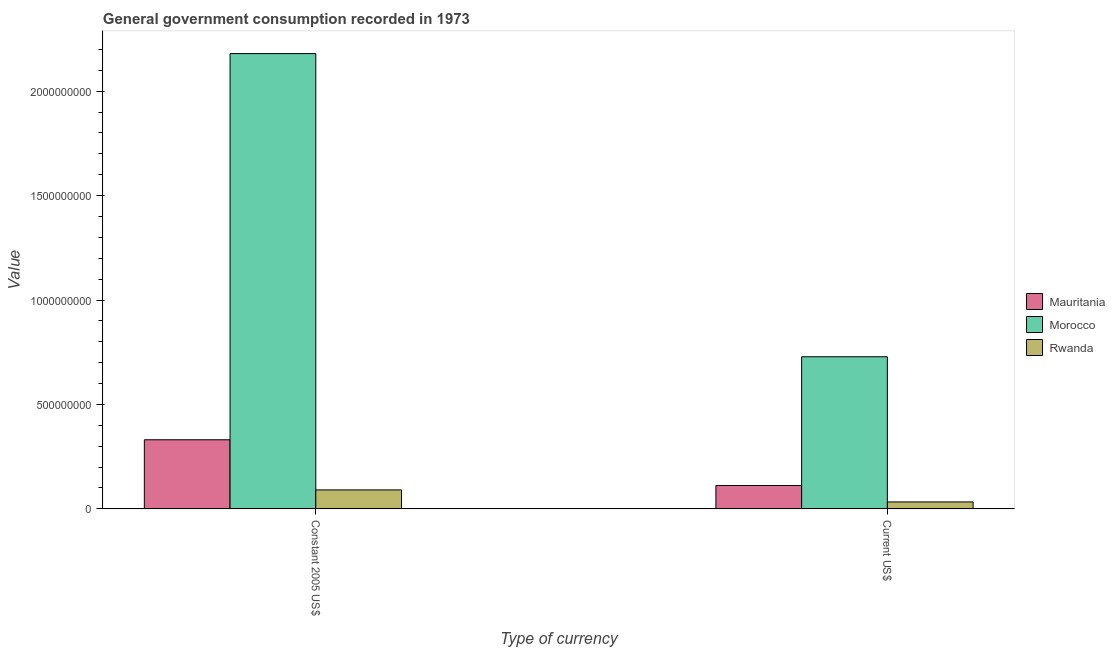How many different coloured bars are there?
Your response must be concise. 3. Are the number of bars per tick equal to the number of legend labels?
Offer a terse response. Yes. How many bars are there on the 1st tick from the left?
Provide a succinct answer. 3. What is the label of the 1st group of bars from the left?
Ensure brevity in your answer.  Constant 2005 US$. What is the value consumed in constant 2005 us$ in Rwanda?
Your answer should be compact. 9.06e+07. Across all countries, what is the maximum value consumed in current us$?
Your answer should be very brief. 7.28e+08. Across all countries, what is the minimum value consumed in current us$?
Give a very brief answer. 3.31e+07. In which country was the value consumed in current us$ maximum?
Offer a terse response. Morocco. In which country was the value consumed in current us$ minimum?
Ensure brevity in your answer.  Rwanda. What is the total value consumed in current us$ in the graph?
Offer a very short reply. 8.73e+08. What is the difference between the value consumed in current us$ in Rwanda and that in Morocco?
Keep it short and to the point. -6.95e+08. What is the difference between the value consumed in current us$ in Rwanda and the value consumed in constant 2005 us$ in Morocco?
Make the answer very short. -2.15e+09. What is the average value consumed in constant 2005 us$ per country?
Give a very brief answer. 8.67e+08. What is the difference between the value consumed in current us$ and value consumed in constant 2005 us$ in Morocco?
Ensure brevity in your answer.  -1.45e+09. In how many countries, is the value consumed in constant 2005 us$ greater than 500000000 ?
Provide a short and direct response. 1. What is the ratio of the value consumed in current us$ in Mauritania to that in Rwanda?
Give a very brief answer. 3.37. In how many countries, is the value consumed in constant 2005 us$ greater than the average value consumed in constant 2005 us$ taken over all countries?
Give a very brief answer. 1. What does the 2nd bar from the left in Constant 2005 US$ represents?
Offer a terse response. Morocco. What does the 1st bar from the right in Current US$ represents?
Ensure brevity in your answer.  Rwanda. Are all the bars in the graph horizontal?
Your answer should be compact. No. How many countries are there in the graph?
Your answer should be very brief. 3. What is the difference between two consecutive major ticks on the Y-axis?
Provide a succinct answer. 5.00e+08. Are the values on the major ticks of Y-axis written in scientific E-notation?
Provide a short and direct response. No. Does the graph contain any zero values?
Keep it short and to the point. No. Does the graph contain grids?
Make the answer very short. No. Where does the legend appear in the graph?
Your answer should be compact. Center right. How many legend labels are there?
Keep it short and to the point. 3. What is the title of the graph?
Your answer should be very brief. General government consumption recorded in 1973. What is the label or title of the X-axis?
Ensure brevity in your answer.  Type of currency. What is the label or title of the Y-axis?
Your answer should be very brief. Value. What is the Value in Mauritania in Constant 2005 US$?
Keep it short and to the point. 3.31e+08. What is the Value in Morocco in Constant 2005 US$?
Ensure brevity in your answer.  2.18e+09. What is the Value in Rwanda in Constant 2005 US$?
Your answer should be very brief. 9.06e+07. What is the Value in Mauritania in Current US$?
Provide a short and direct response. 1.12e+08. What is the Value of Morocco in Current US$?
Keep it short and to the point. 7.28e+08. What is the Value in Rwanda in Current US$?
Offer a very short reply. 3.31e+07. Across all Type of currency, what is the maximum Value of Mauritania?
Offer a terse response. 3.31e+08. Across all Type of currency, what is the maximum Value in Morocco?
Keep it short and to the point. 2.18e+09. Across all Type of currency, what is the maximum Value of Rwanda?
Your answer should be compact. 9.06e+07. Across all Type of currency, what is the minimum Value of Mauritania?
Provide a short and direct response. 1.12e+08. Across all Type of currency, what is the minimum Value in Morocco?
Provide a short and direct response. 7.28e+08. Across all Type of currency, what is the minimum Value of Rwanda?
Give a very brief answer. 3.31e+07. What is the total Value in Mauritania in the graph?
Make the answer very short. 4.43e+08. What is the total Value of Morocco in the graph?
Make the answer very short. 2.91e+09. What is the total Value in Rwanda in the graph?
Your answer should be very brief. 1.24e+08. What is the difference between the Value in Mauritania in Constant 2005 US$ and that in Current US$?
Offer a terse response. 2.19e+08. What is the difference between the Value of Morocco in Constant 2005 US$ and that in Current US$?
Offer a very short reply. 1.45e+09. What is the difference between the Value in Rwanda in Constant 2005 US$ and that in Current US$?
Provide a short and direct response. 5.75e+07. What is the difference between the Value in Mauritania in Constant 2005 US$ and the Value in Morocco in Current US$?
Give a very brief answer. -3.98e+08. What is the difference between the Value of Mauritania in Constant 2005 US$ and the Value of Rwanda in Current US$?
Offer a very short reply. 2.98e+08. What is the difference between the Value in Morocco in Constant 2005 US$ and the Value in Rwanda in Current US$?
Offer a very short reply. 2.15e+09. What is the average Value of Mauritania per Type of currency?
Make the answer very short. 2.21e+08. What is the average Value in Morocco per Type of currency?
Provide a short and direct response. 1.45e+09. What is the average Value in Rwanda per Type of currency?
Give a very brief answer. 6.19e+07. What is the difference between the Value in Mauritania and Value in Morocco in Constant 2005 US$?
Your answer should be compact. -1.85e+09. What is the difference between the Value of Mauritania and Value of Rwanda in Constant 2005 US$?
Your response must be concise. 2.40e+08. What is the difference between the Value of Morocco and Value of Rwanda in Constant 2005 US$?
Your answer should be very brief. 2.09e+09. What is the difference between the Value of Mauritania and Value of Morocco in Current US$?
Offer a very short reply. -6.17e+08. What is the difference between the Value of Mauritania and Value of Rwanda in Current US$?
Ensure brevity in your answer.  7.87e+07. What is the difference between the Value in Morocco and Value in Rwanda in Current US$?
Ensure brevity in your answer.  6.95e+08. What is the ratio of the Value of Mauritania in Constant 2005 US$ to that in Current US$?
Offer a terse response. 2.96. What is the ratio of the Value of Morocco in Constant 2005 US$ to that in Current US$?
Ensure brevity in your answer.  2.99. What is the ratio of the Value in Rwanda in Constant 2005 US$ to that in Current US$?
Ensure brevity in your answer.  2.74. What is the difference between the highest and the second highest Value of Mauritania?
Provide a succinct answer. 2.19e+08. What is the difference between the highest and the second highest Value in Morocco?
Provide a short and direct response. 1.45e+09. What is the difference between the highest and the second highest Value of Rwanda?
Your answer should be very brief. 5.75e+07. What is the difference between the highest and the lowest Value of Mauritania?
Your answer should be compact. 2.19e+08. What is the difference between the highest and the lowest Value of Morocco?
Offer a very short reply. 1.45e+09. What is the difference between the highest and the lowest Value in Rwanda?
Offer a terse response. 5.75e+07. 